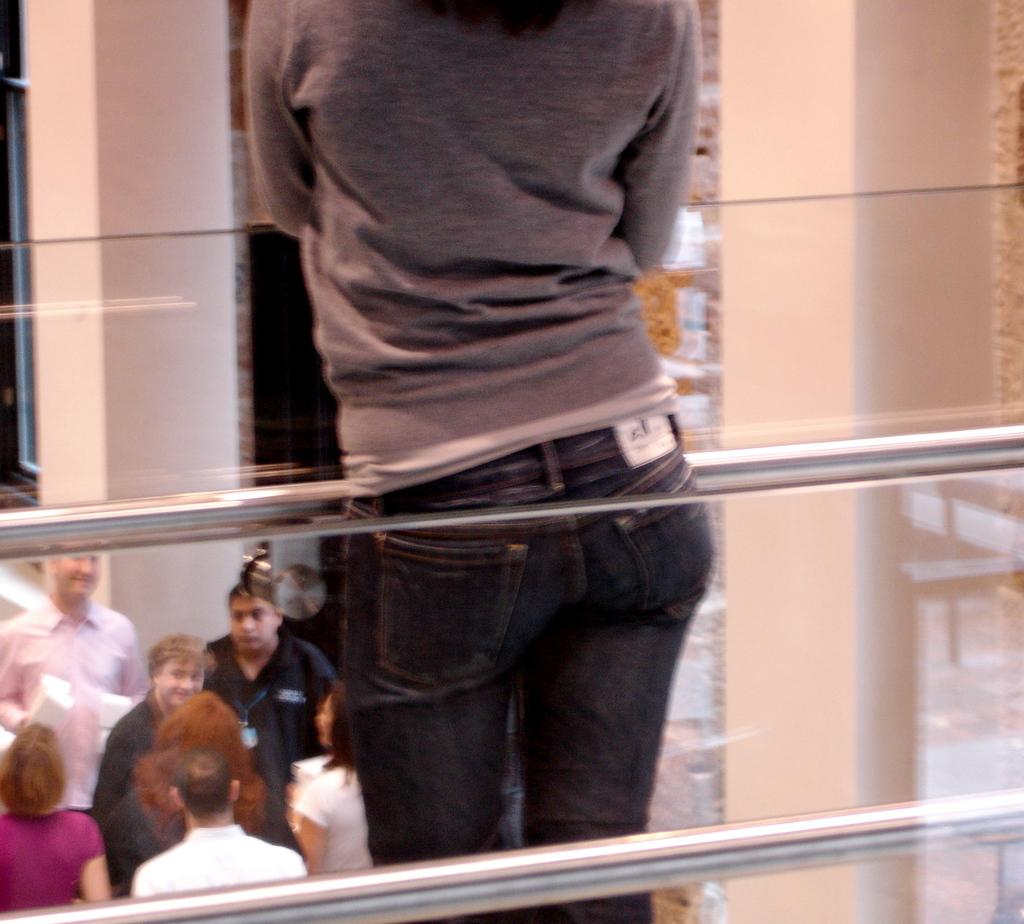How many people are in the image? There is a group of people in the image. Can you describe the clothing of one person in the group? One person in the group is wearing a gray shirt. What objects can be seen in the image besides the people? There are rods visible in the image. What color is the wall in the background? The wall in the background is cream-colored. What type of linen is being used to make the shirts in the image? There is no information about the type of linen used to make the shirts in the image. Can you tell me how much yarn is needed to knit the shirts in the image? There is no indication that the shirts in the image are knitted, nor is there any information about the amount of yarn needed. 